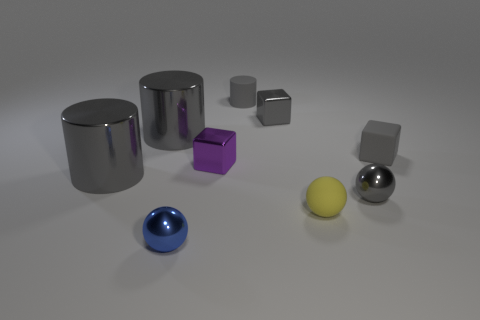Subtract all gray cylinders. How many were subtracted if there are1gray cylinders left? 2 Subtract all cylinders. How many objects are left? 6 Subtract 0 cyan blocks. How many objects are left? 9 Subtract all big gray metal things. Subtract all gray shiny things. How many objects are left? 3 Add 7 small yellow rubber things. How many small yellow rubber things are left? 8 Add 4 large cylinders. How many large cylinders exist? 6 